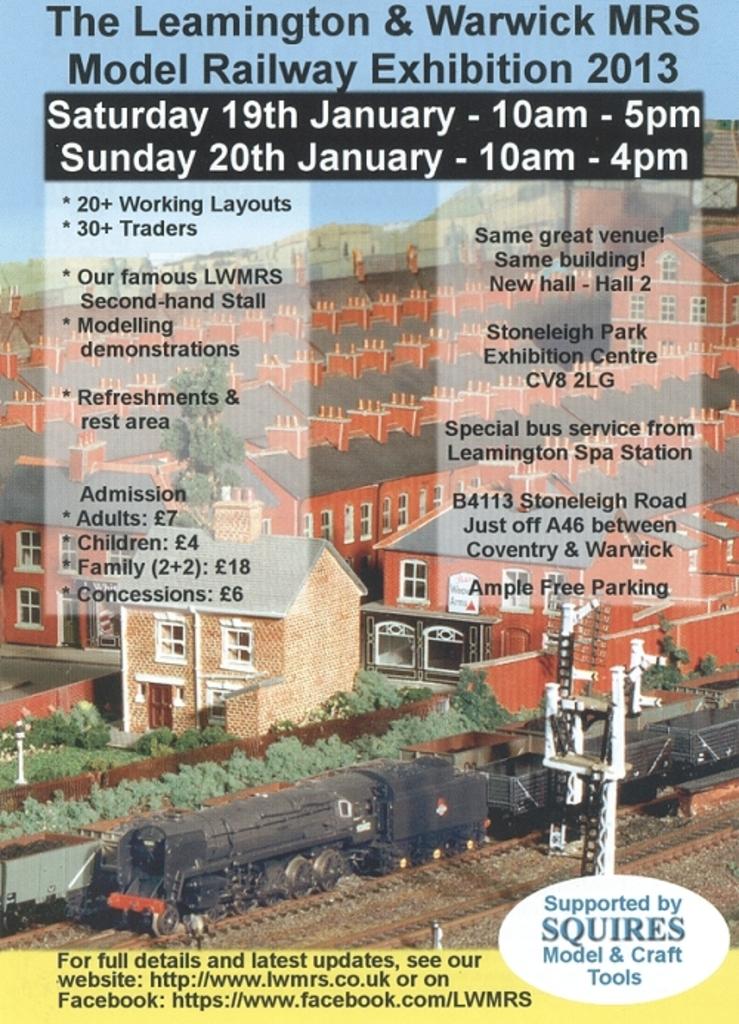What year is listed on the flyer?
Make the answer very short. 2013. What are the times for saturday?
Keep it short and to the point. 10am - 5pm. 